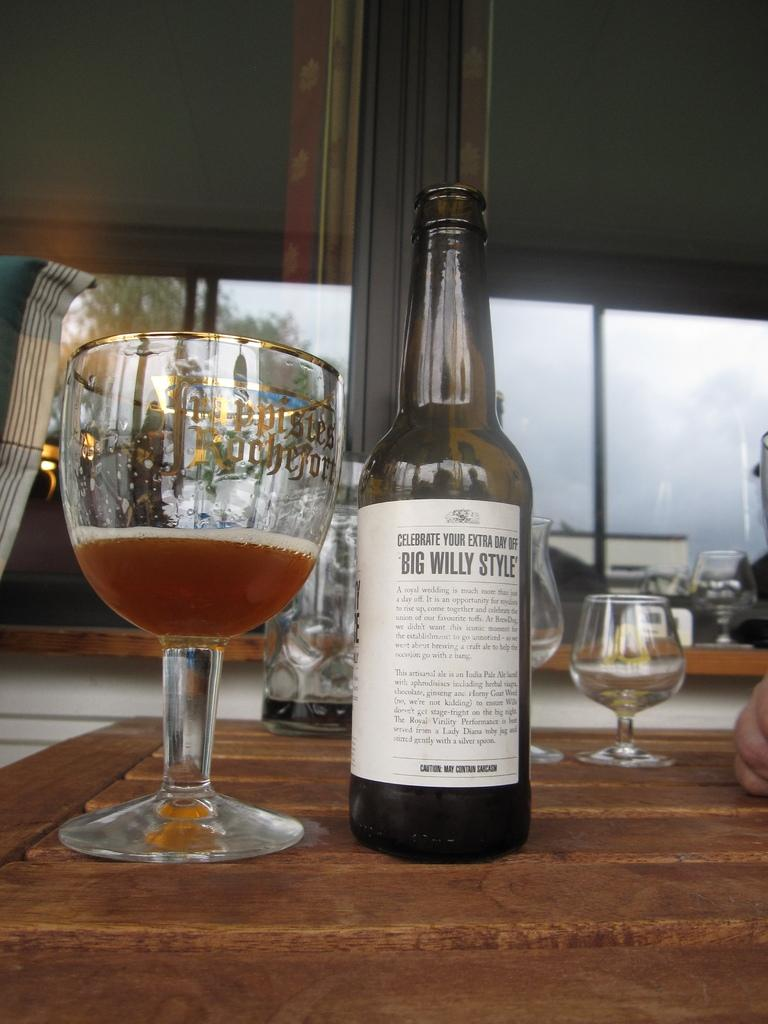What is on the bottle in the image? There is a sticker on the bottle in the image. What is in the glass in the image? There is a drink in the glass in the image. Where are the bottle and glass placed in the image? The bottle and glass are placed on a wooden platform in the image. What can be seen in the background of the image? Windows, a tree, and the sky are visible in the background of the image. Can you see a robin perched on the tree in the image? There is no robin visible in the image; only a tree and the sky are present in the background. Is there a locket hanging from the tree in the image? There is no locket present in the image; only a tree and the sky are visible in the background. 